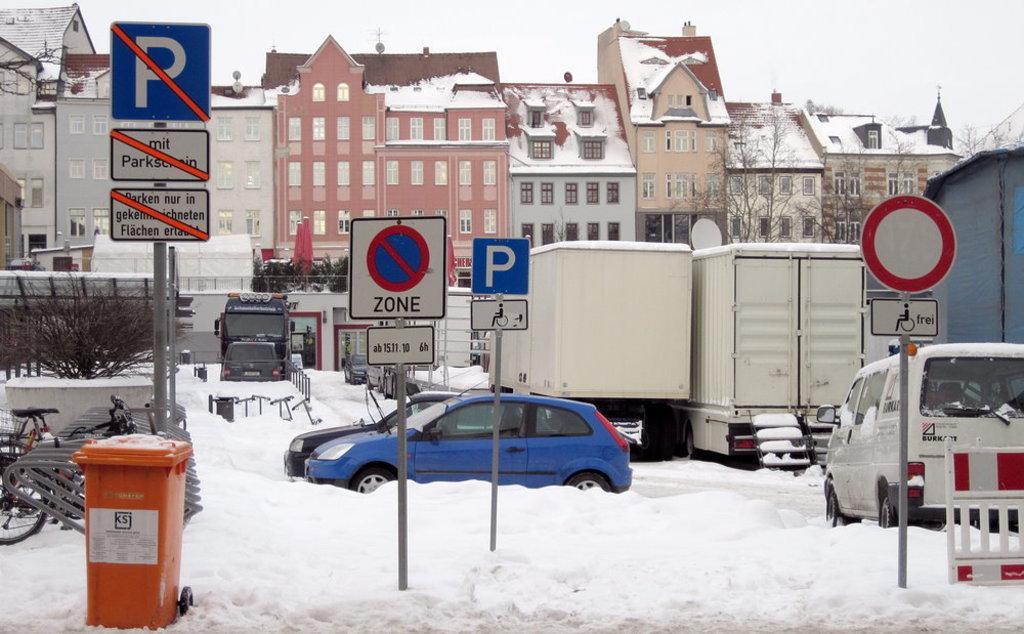Please provide a concise description of this image. In the image we can see there is a ground covered with snow and there are bicycles, cars and vehicles parked on the ground. There is a dustbin and there are sign boards kept on the ground. Behind there are trees and there are buildings covered with snow. There is a clear sky. 